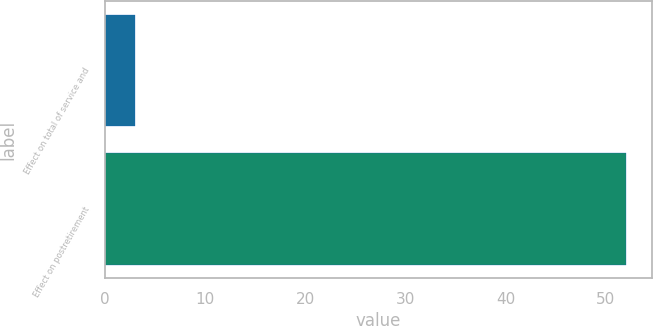Convert chart to OTSL. <chart><loc_0><loc_0><loc_500><loc_500><bar_chart><fcel>Effect on total of service and<fcel>Effect on postretirement<nl><fcel>3<fcel>52<nl></chart> 